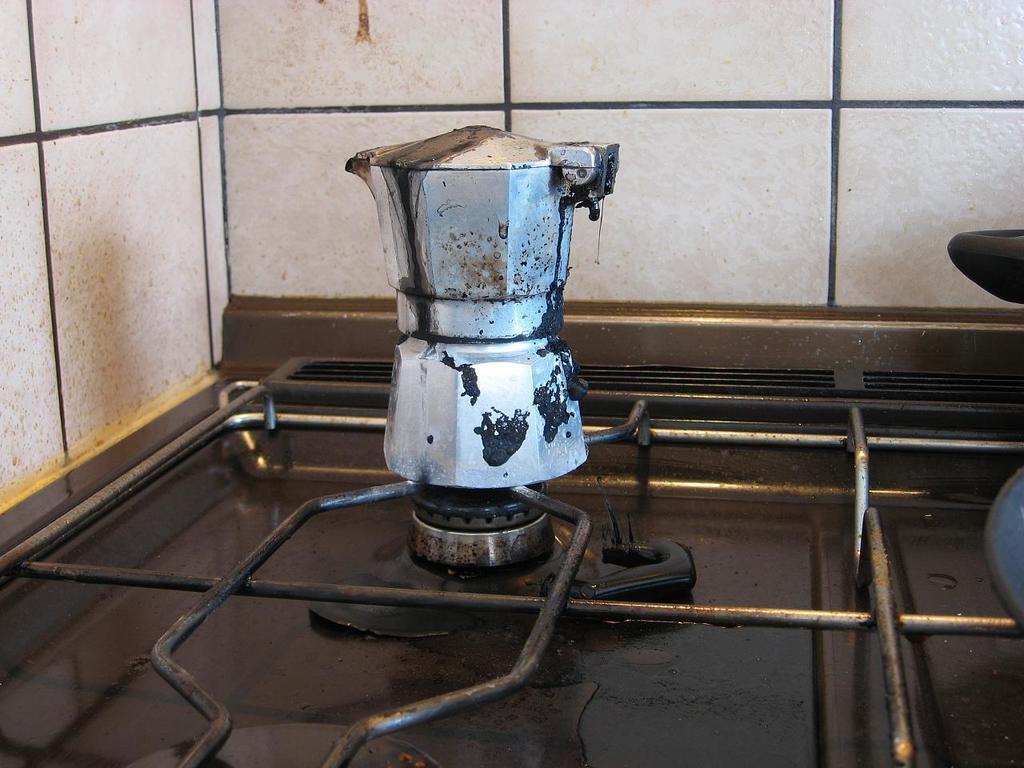Describe this image in one or two sentences. In this picture we can observe a vessel on the stove. We can observe some iron rods here. In the background there are tiles. 